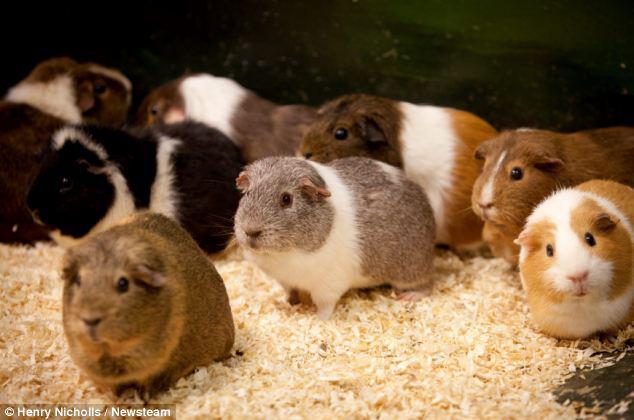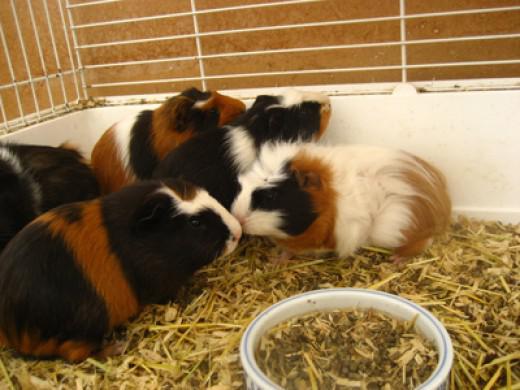The first image is the image on the left, the second image is the image on the right. Assess this claim about the two images: "There is a bowl in the image on the right.". Correct or not? Answer yes or no. Yes. 